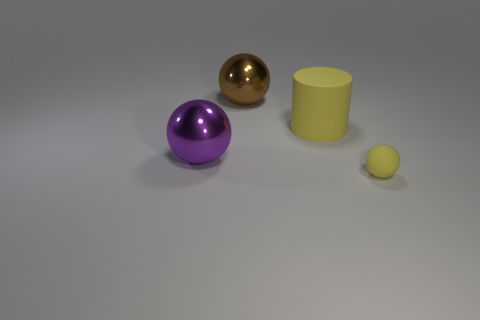There is a small thing that is the same color as the large matte object; what is its shape?
Give a very brief answer. Sphere. Are there any yellow rubber cylinders?
Keep it short and to the point. Yes. There is a yellow cylinder that is the same material as the tiny yellow thing; what size is it?
Your answer should be very brief. Large. What shape is the big object that is on the left side of the metallic ball that is right of the big shiny object in front of the large yellow object?
Provide a succinct answer. Sphere. Are there the same number of large rubber cylinders to the right of the small matte ball and yellow matte spheres?
Your answer should be very brief. No. What is the size of the matte object that is the same color as the tiny matte ball?
Your response must be concise. Large. Is the tiny matte thing the same shape as the big brown object?
Offer a very short reply. Yes. How many objects are either large spheres that are behind the cylinder or purple spheres?
Offer a very short reply. 2. Is the number of big brown shiny objects that are in front of the big purple ball the same as the number of large things that are behind the small thing?
Provide a succinct answer. No. What number of other things are the same shape as the small yellow object?
Your answer should be very brief. 2. 